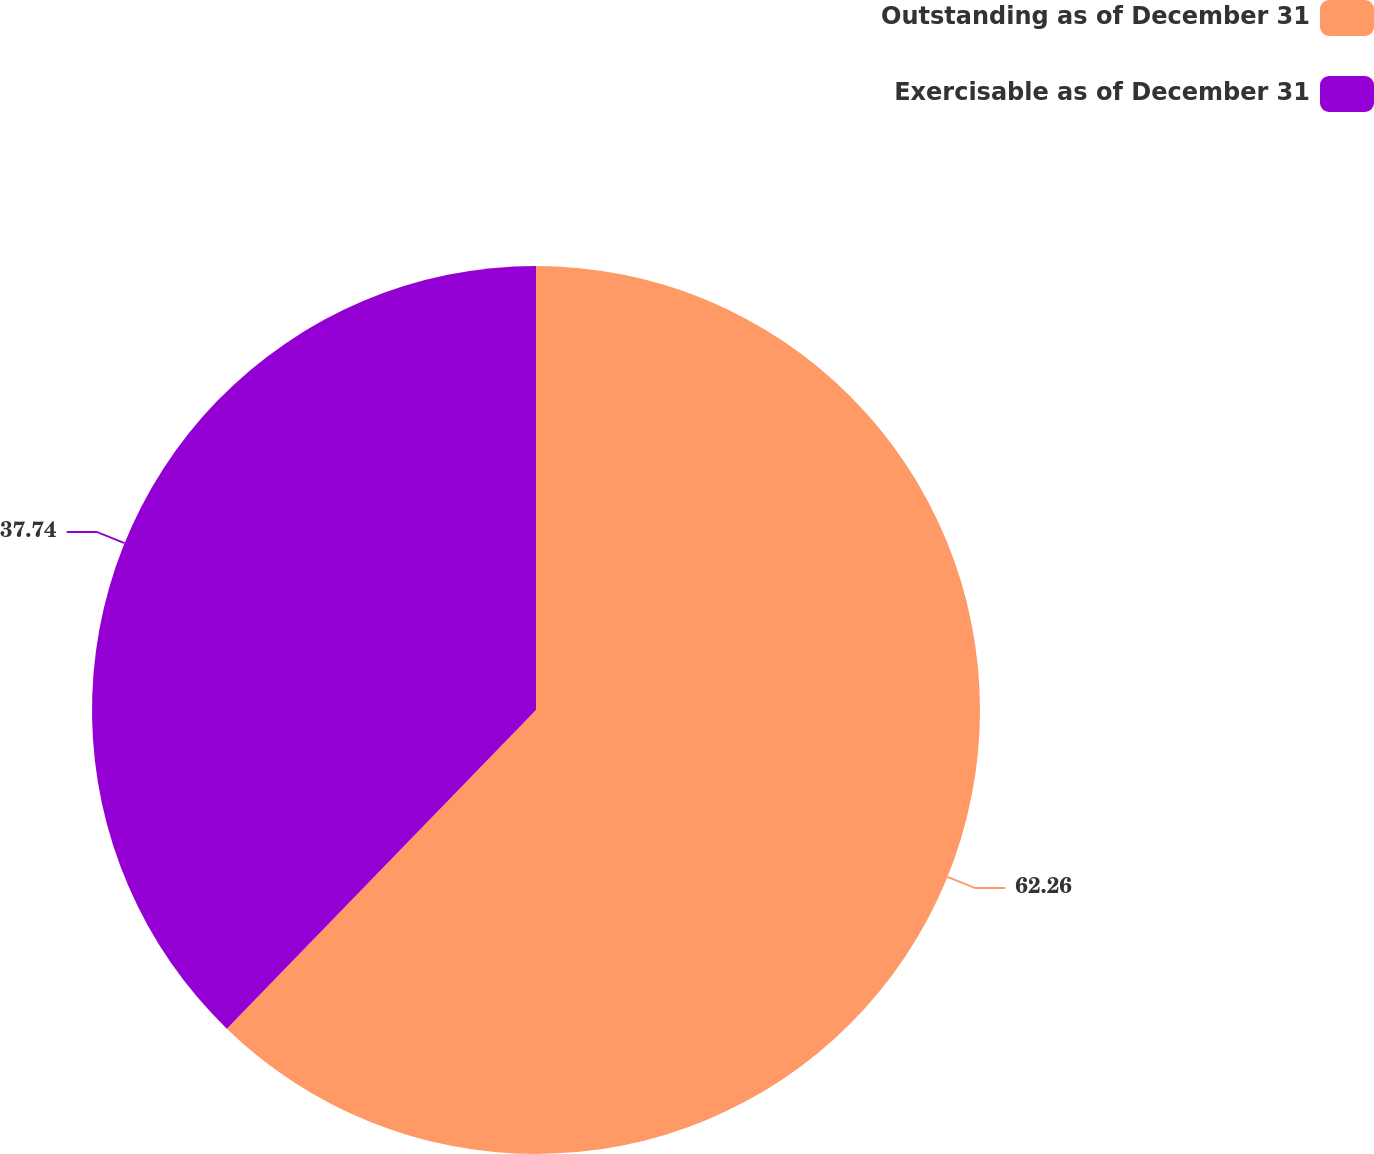<chart> <loc_0><loc_0><loc_500><loc_500><pie_chart><fcel>Outstanding as of December 31<fcel>Exercisable as of December 31<nl><fcel>62.26%<fcel>37.74%<nl></chart> 